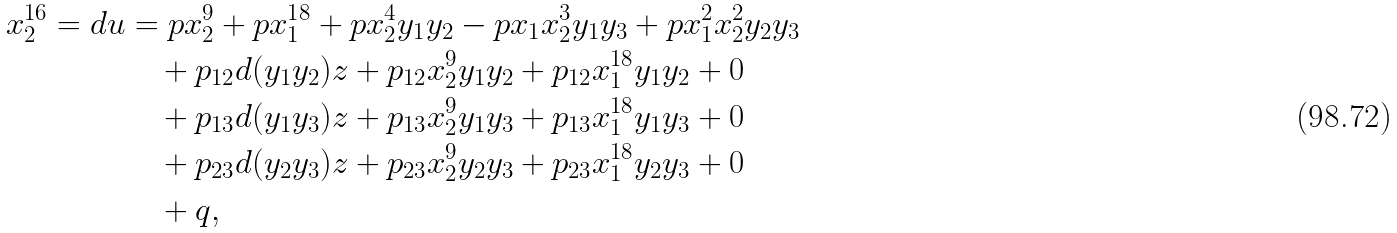<formula> <loc_0><loc_0><loc_500><loc_500>x _ { 2 } ^ { 1 6 } = d u & = p x _ { 2 } ^ { 9 } + p x _ { 1 } ^ { 1 8 } + p x _ { 2 } ^ { 4 } y _ { 1 } y _ { 2 } - p x _ { 1 } x _ { 2 } ^ { 3 } y _ { 1 } y _ { 3 } + p x _ { 1 } ^ { 2 } x _ { 2 } ^ { 2 } y _ { 2 } y _ { 3 } \\ & \quad + p _ { 1 2 } d ( y _ { 1 } y _ { 2 } ) z + p _ { 1 2 } x _ { 2 } ^ { 9 } y _ { 1 } y _ { 2 } + p _ { 1 2 } x _ { 1 } ^ { 1 8 } y _ { 1 } y _ { 2 } + 0 \\ & \quad + p _ { 1 3 } d ( y _ { 1 } y _ { 3 } ) z + p _ { 1 3 } x _ { 2 } ^ { 9 } y _ { 1 } y _ { 3 } + p _ { 1 3 } x _ { 1 } ^ { 1 8 } y _ { 1 } y _ { 3 } + 0 \\ & \quad + p _ { 2 3 } d ( y _ { 2 } y _ { 3 } ) z + p _ { 2 3 } x _ { 2 } ^ { 9 } y _ { 2 } y _ { 3 } + p _ { 2 3 } x _ { 1 } ^ { 1 8 } y _ { 2 } y _ { 3 } + 0 \\ & \quad + q ,</formula> 